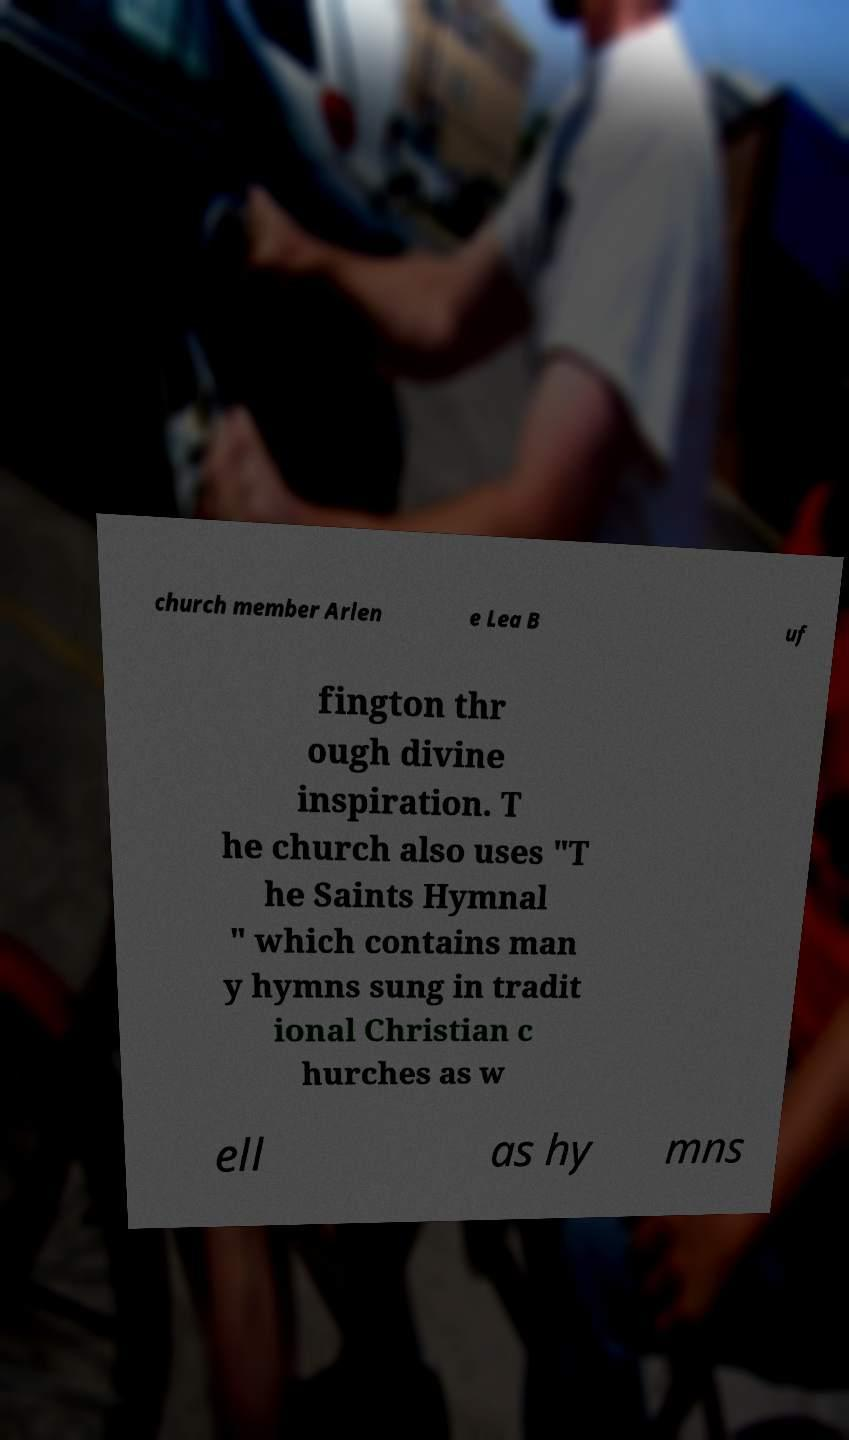For documentation purposes, I need the text within this image transcribed. Could you provide that? church member Arlen e Lea B uf fington thr ough divine inspiration. T he church also uses "T he Saints Hymnal " which contains man y hymns sung in tradit ional Christian c hurches as w ell as hy mns 